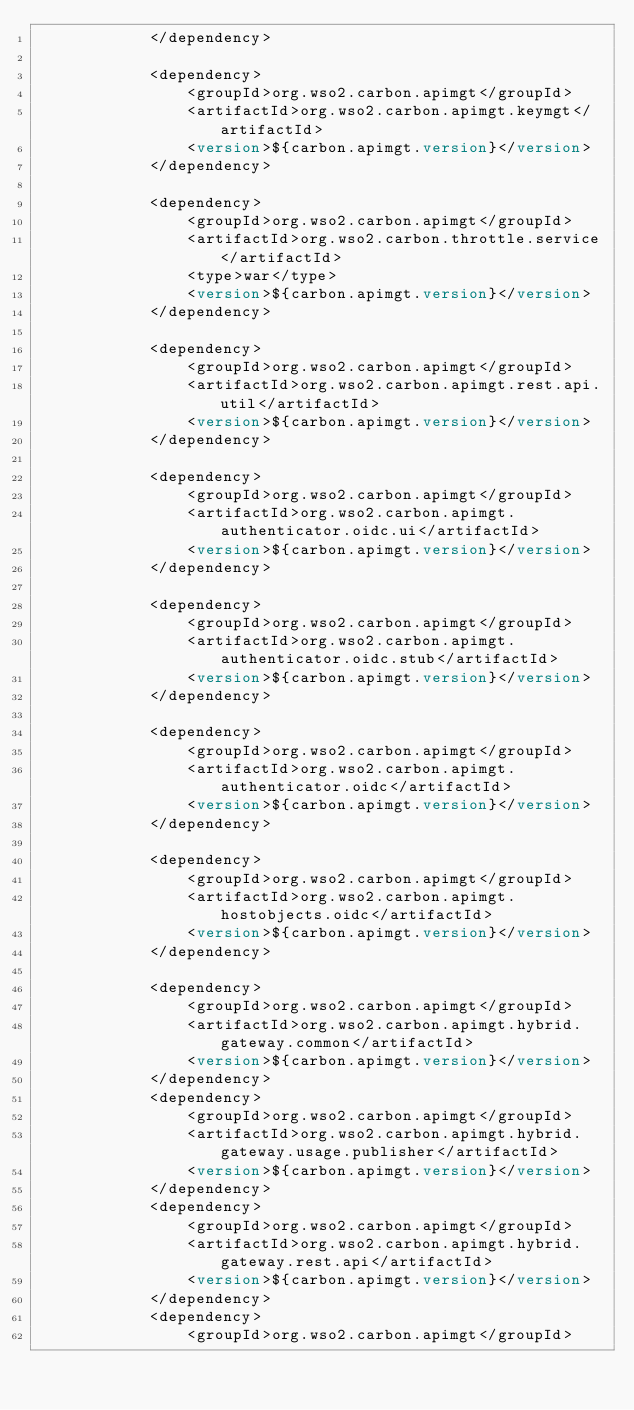<code> <loc_0><loc_0><loc_500><loc_500><_XML_>            </dependency>

            <dependency>
                <groupId>org.wso2.carbon.apimgt</groupId>
                <artifactId>org.wso2.carbon.apimgt.keymgt</artifactId>
                <version>${carbon.apimgt.version}</version>
            </dependency>

            <dependency>
                <groupId>org.wso2.carbon.apimgt</groupId>
                <artifactId>org.wso2.carbon.throttle.service</artifactId>
                <type>war</type>
                <version>${carbon.apimgt.version}</version>
            </dependency>

            <dependency>
                <groupId>org.wso2.carbon.apimgt</groupId>
                <artifactId>org.wso2.carbon.apimgt.rest.api.util</artifactId>
                <version>${carbon.apimgt.version}</version>
            </dependency>

            <dependency>
                <groupId>org.wso2.carbon.apimgt</groupId>
                <artifactId>org.wso2.carbon.apimgt.authenticator.oidc.ui</artifactId>
                <version>${carbon.apimgt.version}</version>
            </dependency>

            <dependency>
                <groupId>org.wso2.carbon.apimgt</groupId>
                <artifactId>org.wso2.carbon.apimgt.authenticator.oidc.stub</artifactId>
                <version>${carbon.apimgt.version}</version>
            </dependency>

            <dependency>
                <groupId>org.wso2.carbon.apimgt</groupId>
                <artifactId>org.wso2.carbon.apimgt.authenticator.oidc</artifactId>
                <version>${carbon.apimgt.version}</version>
            </dependency>

            <dependency>
                <groupId>org.wso2.carbon.apimgt</groupId>
                <artifactId>org.wso2.carbon.apimgt.hostobjects.oidc</artifactId>
                <version>${carbon.apimgt.version}</version>
            </dependency>

            <dependency>
                <groupId>org.wso2.carbon.apimgt</groupId>
                <artifactId>org.wso2.carbon.apimgt.hybrid.gateway.common</artifactId>
                <version>${carbon.apimgt.version}</version>
            </dependency>
            <dependency>
                <groupId>org.wso2.carbon.apimgt</groupId>
                <artifactId>org.wso2.carbon.apimgt.hybrid.gateway.usage.publisher</artifactId>
                <version>${carbon.apimgt.version}</version>
            </dependency>
            <dependency>
                <groupId>org.wso2.carbon.apimgt</groupId>
                <artifactId>org.wso2.carbon.apimgt.hybrid.gateway.rest.api</artifactId>
                <version>${carbon.apimgt.version}</version>
            </dependency>
            <dependency>
                <groupId>org.wso2.carbon.apimgt</groupId></code> 